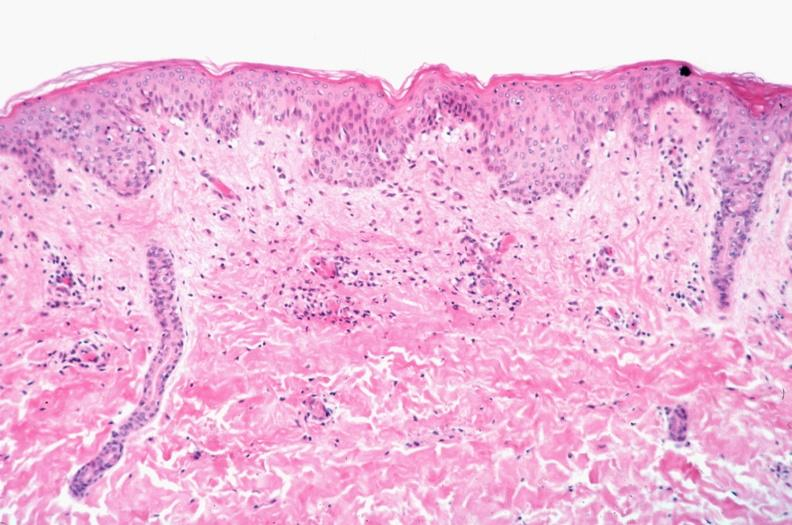does this image show skin?
Answer the question using a single word or phrase. Yes 